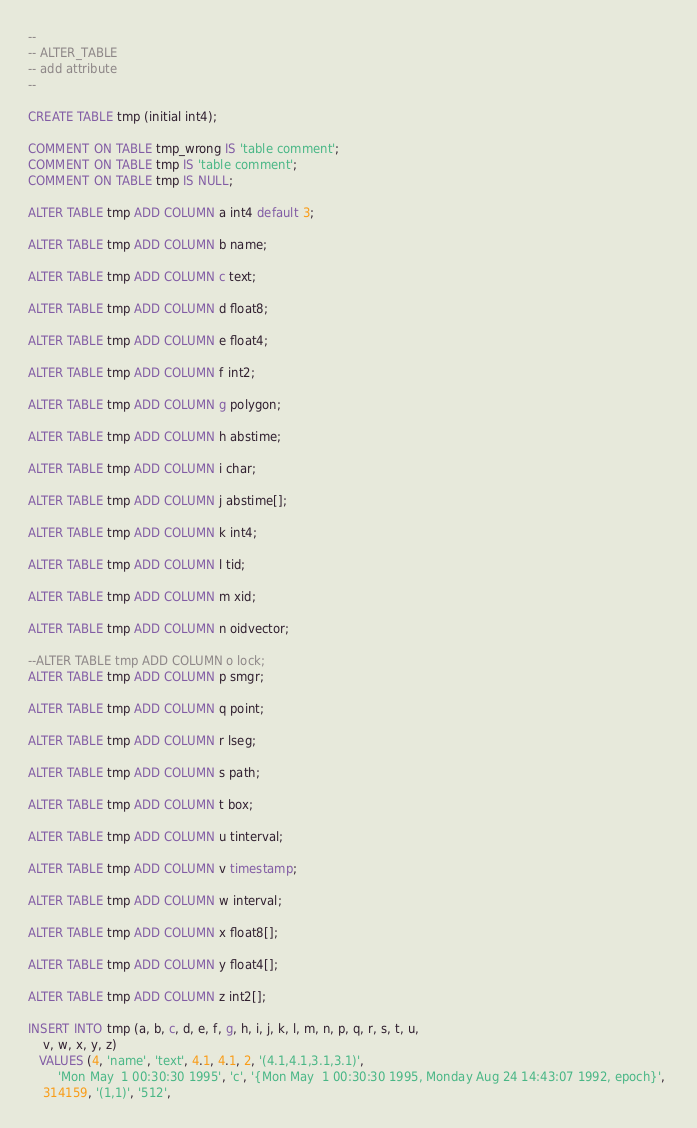<code> <loc_0><loc_0><loc_500><loc_500><_SQL_>--
-- ALTER_TABLE
-- add attribute
--

CREATE TABLE tmp (initial int4);

COMMENT ON TABLE tmp_wrong IS 'table comment';
COMMENT ON TABLE tmp IS 'table comment';
COMMENT ON TABLE tmp IS NULL;

ALTER TABLE tmp ADD COLUMN a int4 default 3;

ALTER TABLE tmp ADD COLUMN b name;

ALTER TABLE tmp ADD COLUMN c text;

ALTER TABLE tmp ADD COLUMN d float8;

ALTER TABLE tmp ADD COLUMN e float4;

ALTER TABLE tmp ADD COLUMN f int2;

ALTER TABLE tmp ADD COLUMN g polygon;

ALTER TABLE tmp ADD COLUMN h abstime;

ALTER TABLE tmp ADD COLUMN i char;

ALTER TABLE tmp ADD COLUMN j abstime[];

ALTER TABLE tmp ADD COLUMN k int4;

ALTER TABLE tmp ADD COLUMN l tid;

ALTER TABLE tmp ADD COLUMN m xid;

ALTER TABLE tmp ADD COLUMN n oidvector;

--ALTER TABLE tmp ADD COLUMN o lock;
ALTER TABLE tmp ADD COLUMN p smgr;

ALTER TABLE tmp ADD COLUMN q point;

ALTER TABLE tmp ADD COLUMN r lseg;

ALTER TABLE tmp ADD COLUMN s path;

ALTER TABLE tmp ADD COLUMN t box;

ALTER TABLE tmp ADD COLUMN u tinterval;

ALTER TABLE tmp ADD COLUMN v timestamp;

ALTER TABLE tmp ADD COLUMN w interval;

ALTER TABLE tmp ADD COLUMN x float8[];

ALTER TABLE tmp ADD COLUMN y float4[];

ALTER TABLE tmp ADD COLUMN z int2[];

INSERT INTO tmp (a, b, c, d, e, f, g, h, i, j, k, l, m, n, p, q, r, s, t, u,
	v, w, x, y, z)
   VALUES (4, 'name', 'text', 4.1, 4.1, 2, '(4.1,4.1,3.1,3.1)', 
        'Mon May  1 00:30:30 1995', 'c', '{Mon May  1 00:30:30 1995, Monday Aug 24 14:43:07 1992, epoch}', 
	314159, '(1,1)', '512',</code> 